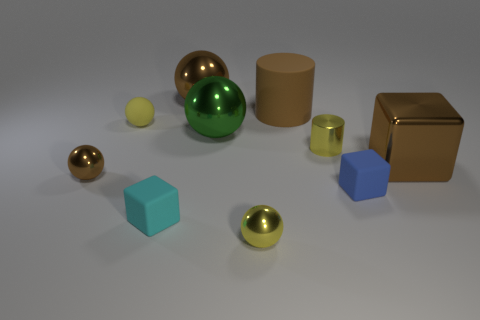How many other things are there of the same color as the big cylinder?
Offer a terse response. 3. Is the shape of the cyan matte thing the same as the big brown object in front of the large brown cylinder?
Provide a succinct answer. Yes. There is a matte thing that is on the left side of the big brown sphere and behind the small brown shiny object; how big is it?
Your answer should be compact. Small. How many brown shiny spheres are there?
Your response must be concise. 2. There is a cyan thing that is the same size as the metal cylinder; what is its material?
Offer a very short reply. Rubber. Is there another sphere of the same size as the yellow shiny ball?
Provide a succinct answer. Yes. There is a tiny cube in front of the small blue matte thing; is its color the same as the tiny rubber thing behind the yellow cylinder?
Your answer should be compact. No. What number of metal things are large green cylinders or blue blocks?
Your response must be concise. 0. There is a small matte thing on the right side of the small metal ball that is to the right of the small cyan matte thing; how many metal objects are left of it?
Give a very brief answer. 5. There is a ball that is the same material as the blue block; what size is it?
Provide a short and direct response. Small. 